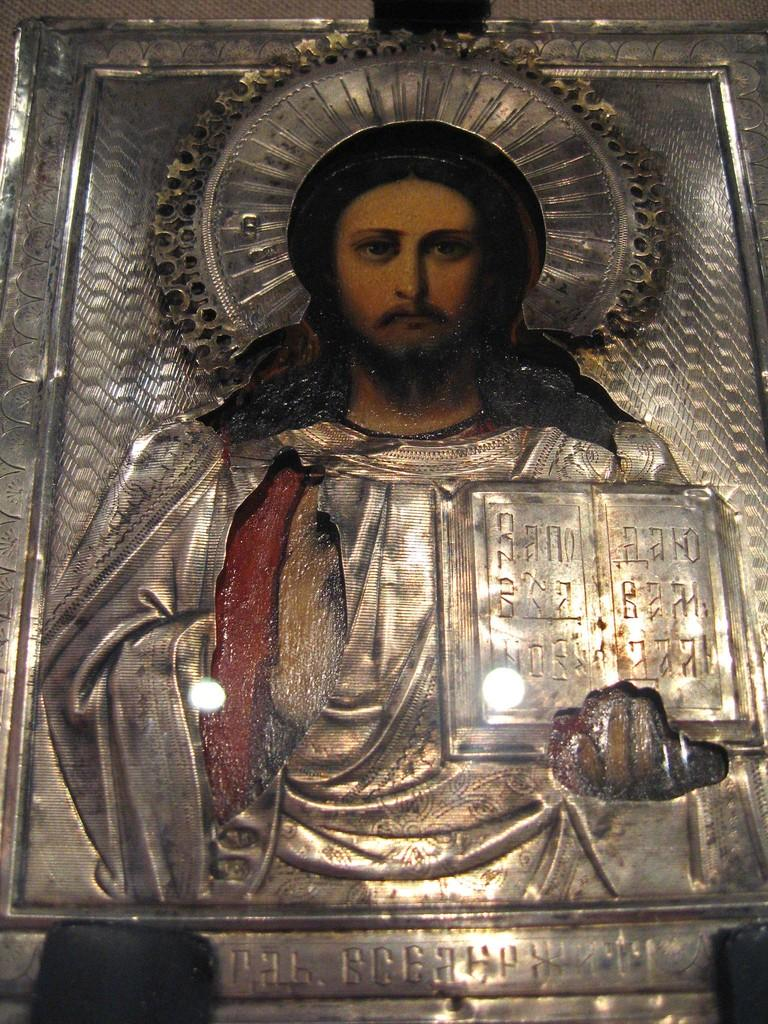What type of object is depicted in the image? There is a metal carving in the image. Can you describe the person in the image? There is a person in the image. Where is the text located in the image? There is text on the right side and at the bottom of the image. What building is the person using in the image? There is no building present in the image. What is the person feeling ashamed about in the image? There is no indication of shame or any specific emotion in the image. 